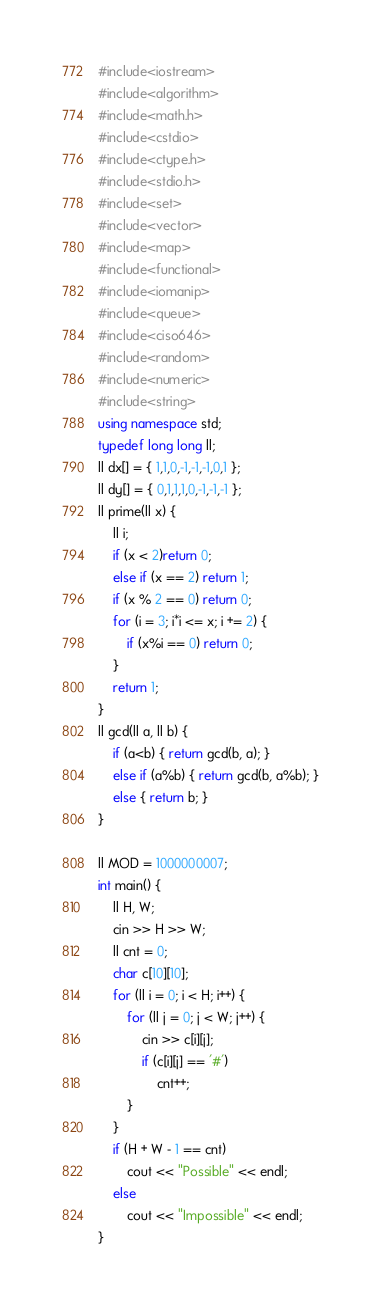<code> <loc_0><loc_0><loc_500><loc_500><_C++_>#include<iostream>
#include<algorithm>
#include<math.h>
#include<cstdio>
#include<ctype.h>
#include<stdio.h>
#include<set>
#include<vector>
#include<map>
#include<functional>
#include<iomanip>
#include<queue>
#include<ciso646>
#include<random>
#include<numeric>
#include<string>
using namespace std;
typedef long long ll;
ll dx[] = { 1,1,0,-1,-1,-1,0,1 };
ll dy[] = { 0,1,1,1,0,-1,-1,-1 };
ll prime(ll x) {
	ll i;
	if (x < 2)return 0;
	else if (x == 2) return 1;
	if (x % 2 == 0) return 0;
	for (i = 3; i*i <= x; i += 2) {
		if (x%i == 0) return 0;
	}
	return 1;
}
ll gcd(ll a, ll b) {
	if (a<b) { return gcd(b, a); }
	else if (a%b) { return gcd(b, a%b); }
	else { return b; }
}

ll MOD = 1000000007;
int main() {
	ll H, W;
	cin >> H >> W;
	ll cnt = 0;
	char c[10][10];
	for (ll i = 0; i < H; i++) {
		for (ll j = 0; j < W; j++) {
			cin >> c[i][j];
			if (c[i][j] == '#')
				cnt++;
		}
	}
	if (H + W - 1 == cnt)
		cout << "Possible" << endl;
	else
		cout << "Impossible" << endl;
}
</code> 